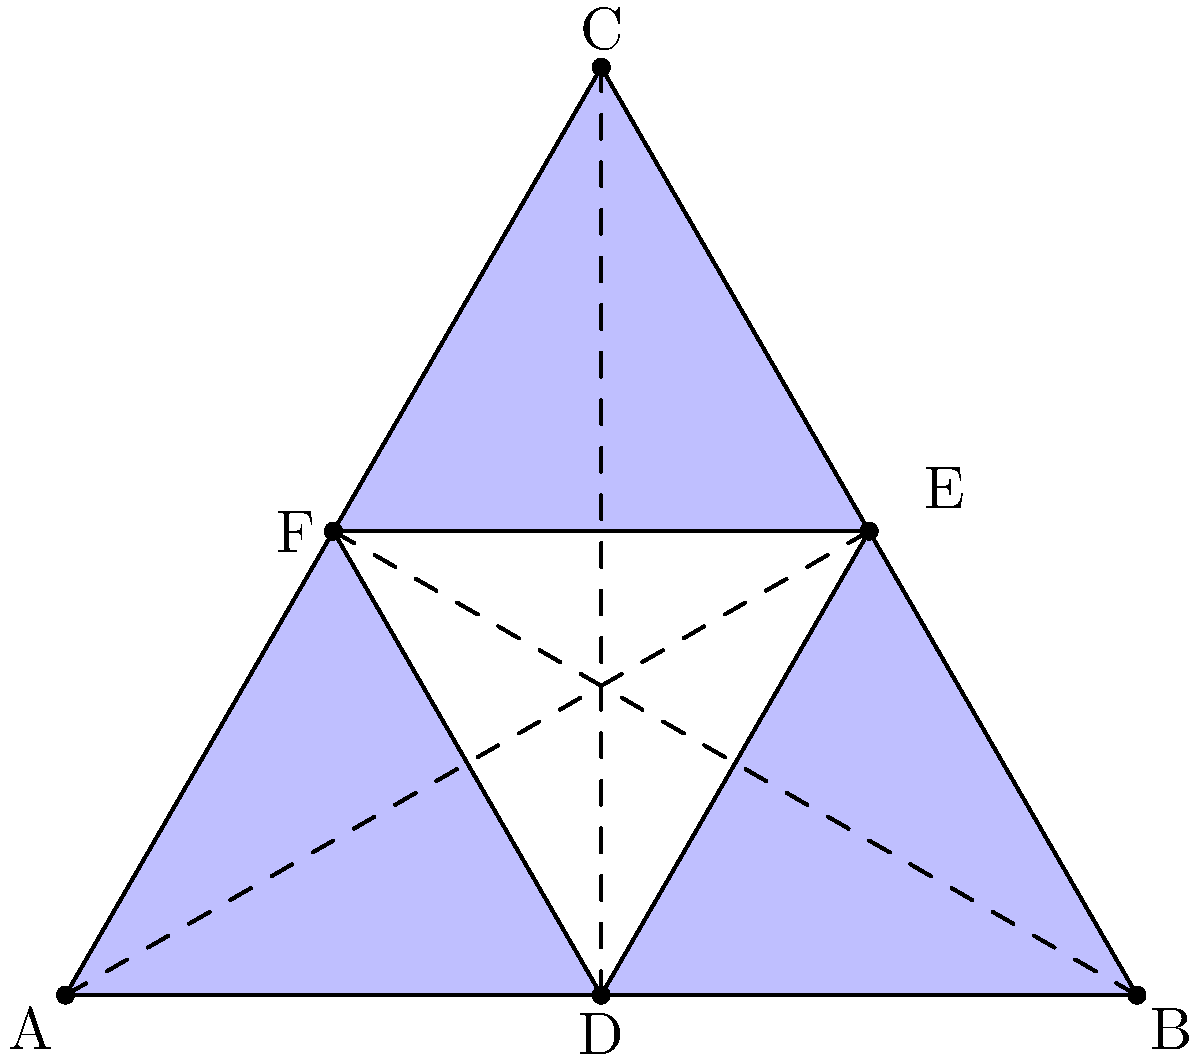In this Islamic geometric pattern, an equilateral triangle ABC is inscribed with another equilateral triangle DEF. If the area of triangle ABC is 24 square units, what is the area of triangle DEF? Let's approach this step-by-step:

1) First, recall that in an equilateral triangle, the centroid divides each median in the ratio 2:1 (the centroid is twice as close to the midpoint of a side as it is to the opposite vertex).

2) In this figure, D, E, and F are midpoints of the sides of triangle ABC, and the lines AD, BE, and CF are medians of triangle ABC.

3) Triangle DEF is formed by connecting these midpoints, and its vertices lie on the medians of triangle ABC.

4) The centroid of triangle ABC is the point where all three medians intersect. It's also the centroid of triangle DEF.

5) Due to the centroid theorem, triangle DEF is similar to triangle ABC with a scale factor of 1/3.

6) For similar triangles, the ratio of their areas is equal to the square of the ratio of their corresponding sides.

7) Therefore, the ratio of the area of triangle DEF to the area of triangle ABC is:

   $$\frac{\text{Area DEF}}{\text{Area ABC}} = \left(\frac{1}{3}\right)^2 = \frac{1}{9}$$

8) Given that the area of triangle ABC is 24 square units:

   $$\text{Area DEF} = \frac{1}{9} \times 24 = \frac{24}{9} = \frac{8}{3}$$

Therefore, the area of triangle DEF is $\frac{8}{3}$ square units.
Answer: $\frac{8}{3}$ square units 